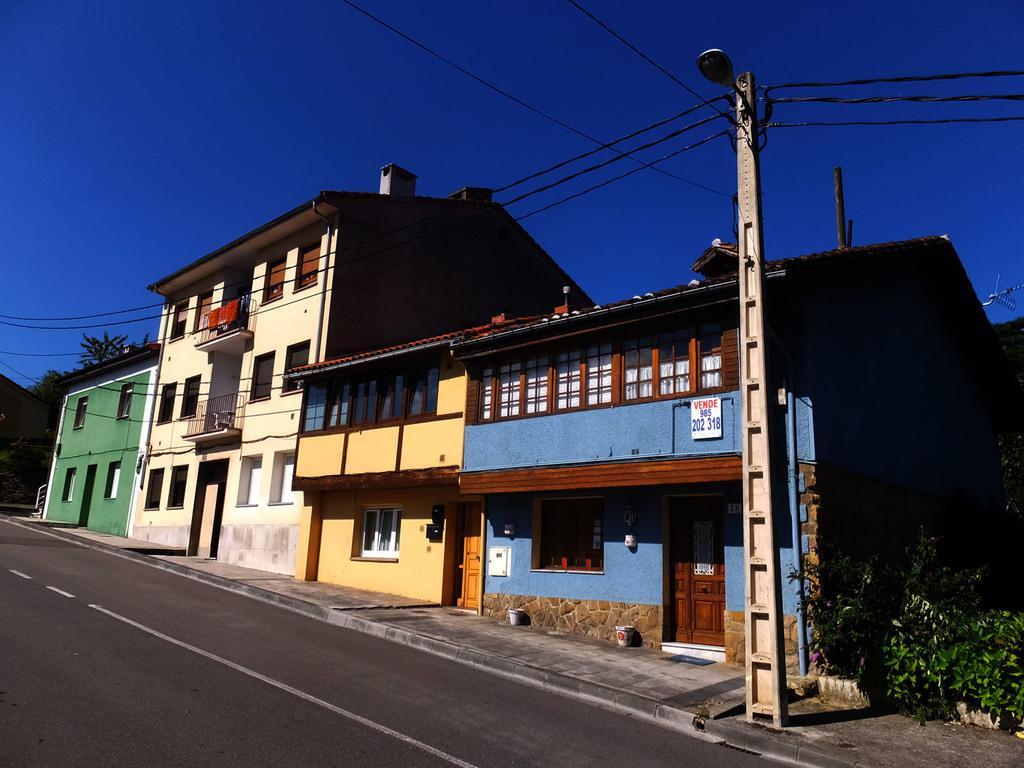In one or two sentences, can you explain what this image depicts? In the image there is a road and beside the road there are houses and trees. 